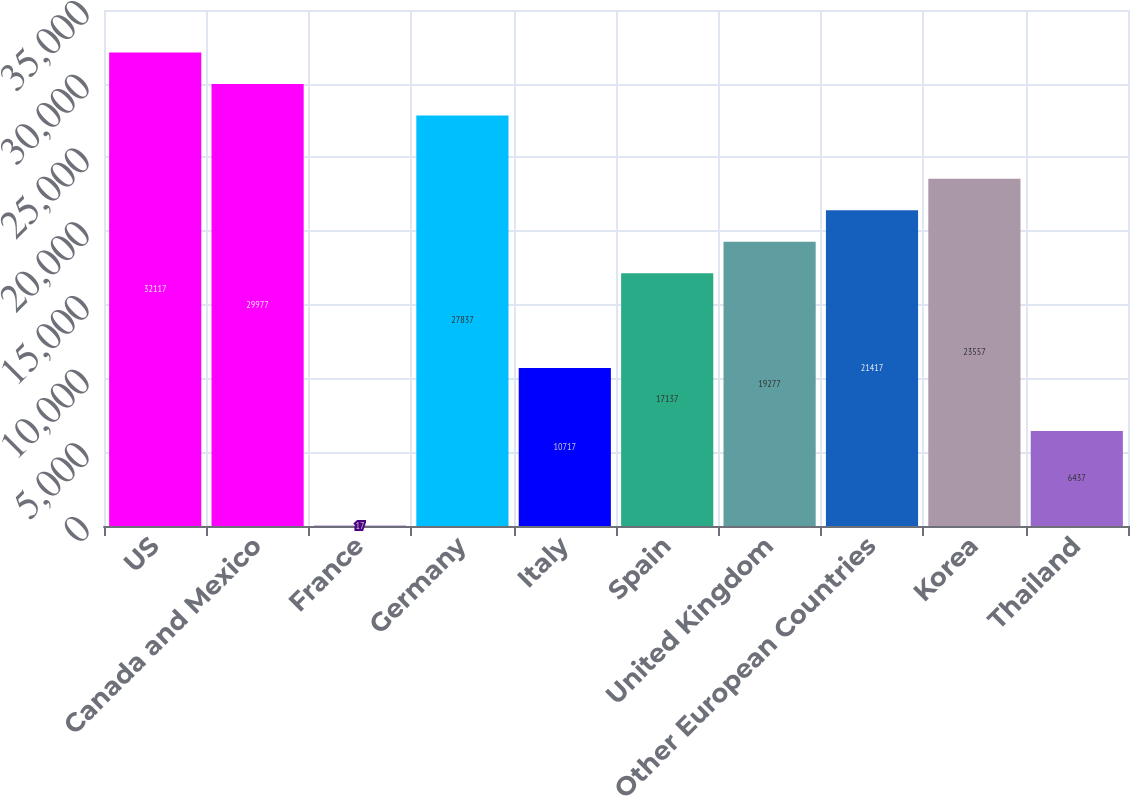Convert chart to OTSL. <chart><loc_0><loc_0><loc_500><loc_500><bar_chart><fcel>US<fcel>Canada and Mexico<fcel>France<fcel>Germany<fcel>Italy<fcel>Spain<fcel>United Kingdom<fcel>Other European Countries<fcel>Korea<fcel>Thailand<nl><fcel>32117<fcel>29977<fcel>17<fcel>27837<fcel>10717<fcel>17137<fcel>19277<fcel>21417<fcel>23557<fcel>6437<nl></chart> 